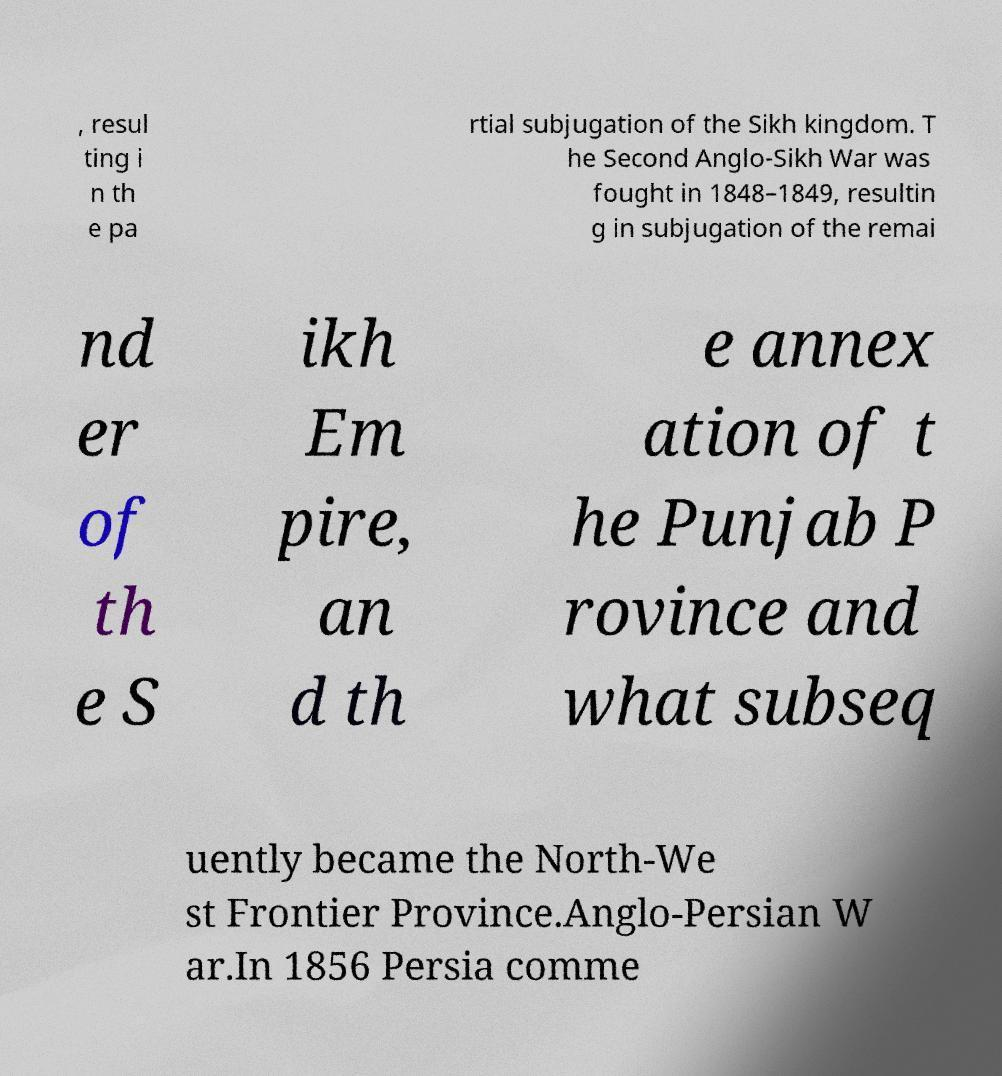Can you accurately transcribe the text from the provided image for me? , resul ting i n th e pa rtial subjugation of the Sikh kingdom. T he Second Anglo-Sikh War was fought in 1848–1849, resultin g in subjugation of the remai nd er of th e S ikh Em pire, an d th e annex ation of t he Punjab P rovince and what subseq uently became the North-We st Frontier Province.Anglo-Persian W ar.In 1856 Persia comme 